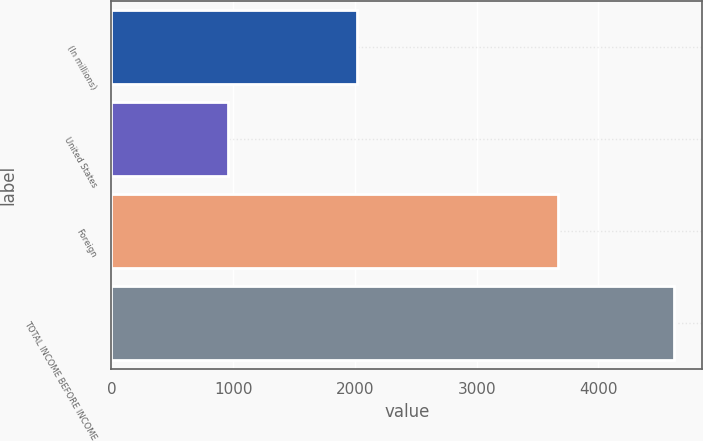Convert chart. <chart><loc_0><loc_0><loc_500><loc_500><bar_chart><fcel>(In millions)<fcel>United States<fcel>Foreign<fcel>TOTAL INCOME BEFORE INCOME<nl><fcel>2016<fcel>956<fcel>3667<fcel>4623<nl></chart> 